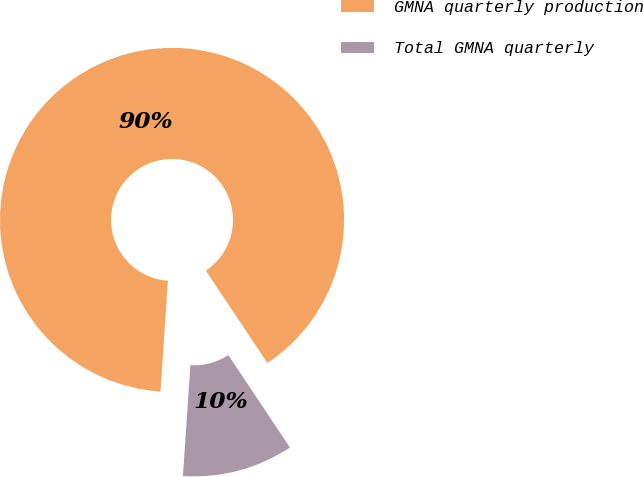<chart> <loc_0><loc_0><loc_500><loc_500><pie_chart><fcel>GMNA quarterly production<fcel>Total GMNA quarterly<nl><fcel>89.57%<fcel>10.43%<nl></chart> 